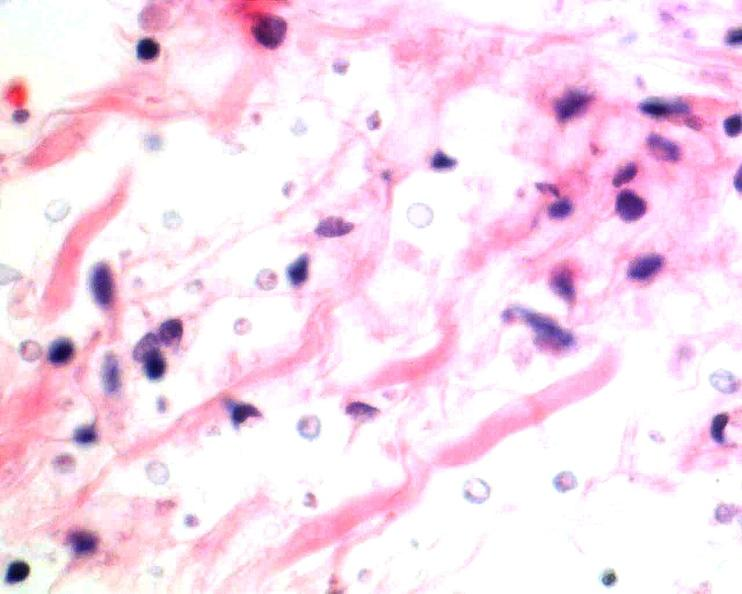does this image show brain, cryptococcal meningitis, he?
Answer the question using a single word or phrase. Yes 